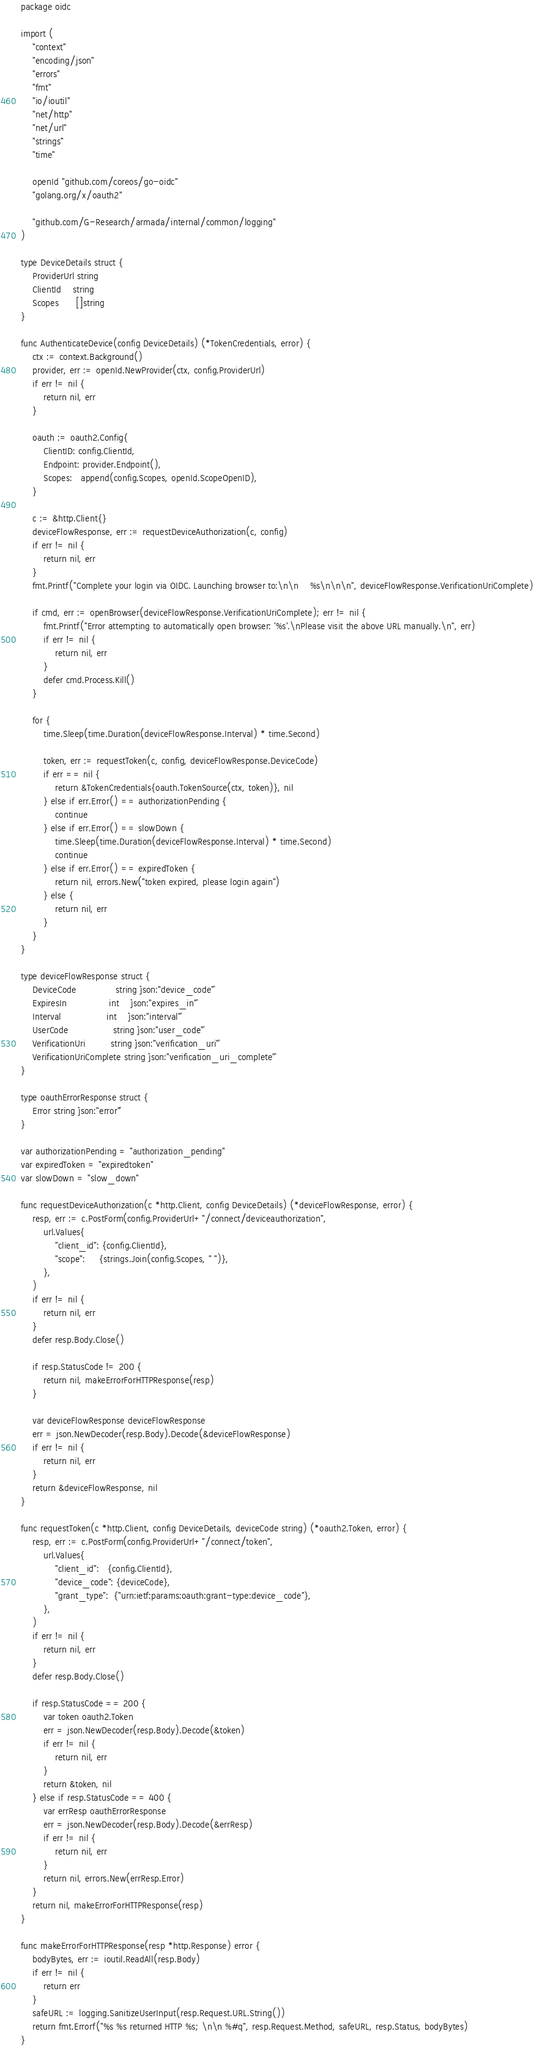Convert code to text. <code><loc_0><loc_0><loc_500><loc_500><_Go_>package oidc

import (
	"context"
	"encoding/json"
	"errors"
	"fmt"
	"io/ioutil"
	"net/http"
	"net/url"
	"strings"
	"time"

	openId "github.com/coreos/go-oidc"
	"golang.org/x/oauth2"

	"github.com/G-Research/armada/internal/common/logging"
)

type DeviceDetails struct {
	ProviderUrl string
	ClientId    string
	Scopes      []string
}

func AuthenticateDevice(config DeviceDetails) (*TokenCredentials, error) {
	ctx := context.Background()
	provider, err := openId.NewProvider(ctx, config.ProviderUrl)
	if err != nil {
		return nil, err
	}

	oauth := oauth2.Config{
		ClientID: config.ClientId,
		Endpoint: provider.Endpoint(),
		Scopes:   append(config.Scopes, openId.ScopeOpenID),
	}

	c := &http.Client{}
	deviceFlowResponse, err := requestDeviceAuthorization(c, config)
	if err != nil {
		return nil, err
	}
	fmt.Printf("Complete your login via OIDC. Launching browser to:\n\n    %s\n\n\n", deviceFlowResponse.VerificationUriComplete)

	if cmd, err := openBrowser(deviceFlowResponse.VerificationUriComplete); err != nil {
		fmt.Printf("Error attempting to automatically open browser: '%s'.\nPlease visit the above URL manually.\n", err)
		if err != nil {
			return nil, err
		}
		defer cmd.Process.Kill()
	}

	for {
		time.Sleep(time.Duration(deviceFlowResponse.Interval) * time.Second)

		token, err := requestToken(c, config, deviceFlowResponse.DeviceCode)
		if err == nil {
			return &TokenCredentials{oauth.TokenSource(ctx, token)}, nil
		} else if err.Error() == authorizationPending {
			continue
		} else if err.Error() == slowDown {
			time.Sleep(time.Duration(deviceFlowResponse.Interval) * time.Second)
			continue
		} else if err.Error() == expiredToken {
			return nil, errors.New("token expired, please login again")
		} else {
			return nil, err
		}
	}
}

type deviceFlowResponse struct {
	DeviceCode              string `json:"device_code"`
	ExpiresIn               int    `json:"expires_in"`
	Interval                int    `json:"interval"`
	UserCode                string `json:"user_code"`
	VerificationUri         string `json:"verification_uri"`
	VerificationUriComplete string `json:"verification_uri_complete"`
}

type oauthErrorResponse struct {
	Error string `json:"error"`
}

var authorizationPending = "authorization_pending"
var expiredToken = "expiredtoken"
var slowDown = "slow_down"

func requestDeviceAuthorization(c *http.Client, config DeviceDetails) (*deviceFlowResponse, error) {
	resp, err := c.PostForm(config.ProviderUrl+"/connect/deviceauthorization",
		url.Values{
			"client_id": {config.ClientId},
			"scope":     {strings.Join(config.Scopes, " ")},
		},
	)
	if err != nil {
		return nil, err
	}
	defer resp.Body.Close()

	if resp.StatusCode != 200 {
		return nil, makeErrorForHTTPResponse(resp)
	}

	var deviceFlowResponse deviceFlowResponse
	err = json.NewDecoder(resp.Body).Decode(&deviceFlowResponse)
	if err != nil {
		return nil, err
	}
	return &deviceFlowResponse, nil
}

func requestToken(c *http.Client, config DeviceDetails, deviceCode string) (*oauth2.Token, error) {
	resp, err := c.PostForm(config.ProviderUrl+"/connect/token",
		url.Values{
			"client_id":   {config.ClientId},
			"device_code": {deviceCode},
			"grant_type":  {"urn:ietf:params:oauth:grant-type:device_code"},
		},
	)
	if err != nil {
		return nil, err
	}
	defer resp.Body.Close()

	if resp.StatusCode == 200 {
		var token oauth2.Token
		err = json.NewDecoder(resp.Body).Decode(&token)
		if err != nil {
			return nil, err
		}
		return &token, nil
	} else if resp.StatusCode == 400 {
		var errResp oauthErrorResponse
		err = json.NewDecoder(resp.Body).Decode(&errResp)
		if err != nil {
			return nil, err
		}
		return nil, errors.New(errResp.Error)
	}
	return nil, makeErrorForHTTPResponse(resp)
}

func makeErrorForHTTPResponse(resp *http.Response) error {
	bodyBytes, err := ioutil.ReadAll(resp.Body)
	if err != nil {
		return err
	}
	safeURL := logging.SanitizeUserInput(resp.Request.URL.String())
	return fmt.Errorf("%s %s returned HTTP %s; \n\n %#q", resp.Request.Method, safeURL, resp.Status, bodyBytes)
}
</code> 